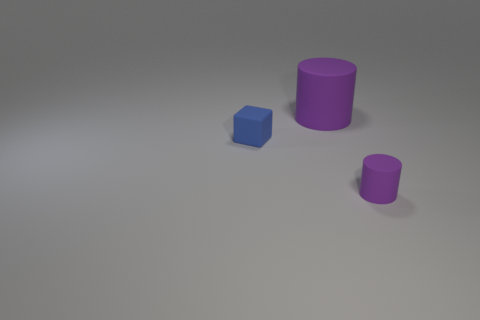Add 2 small purple rubber things. How many objects exist? 5 Add 3 big yellow metal cubes. How many big yellow metal cubes exist? 3 Subtract 0 gray balls. How many objects are left? 3 Subtract all cubes. How many objects are left? 2 Subtract all gray cylinders. Subtract all gray cubes. How many cylinders are left? 2 Subtract all small blue things. Subtract all large yellow rubber things. How many objects are left? 2 Add 2 large rubber objects. How many large rubber objects are left? 3 